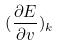Convert formula to latex. <formula><loc_0><loc_0><loc_500><loc_500>( \frac { \partial E } { \partial v } ) _ { k }</formula> 